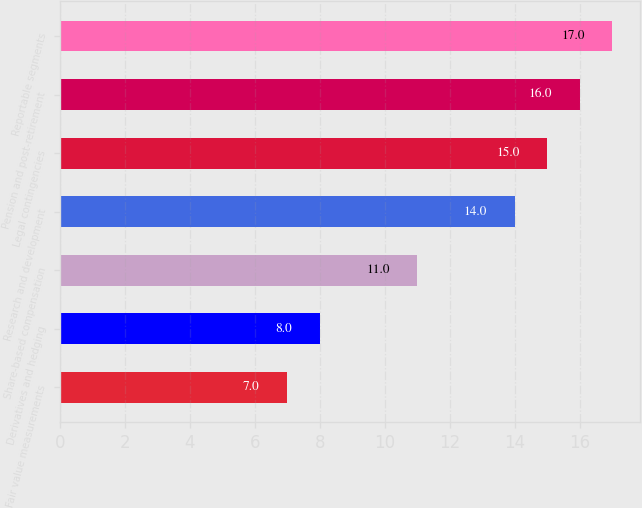<chart> <loc_0><loc_0><loc_500><loc_500><bar_chart><fcel>Fair value measurements<fcel>Derivatives and hedging<fcel>Share-based compensation<fcel>Research and development<fcel>Legal contingencies<fcel>Pension and post-retirement<fcel>Reportable segments<nl><fcel>7<fcel>8<fcel>11<fcel>14<fcel>15<fcel>16<fcel>17<nl></chart> 